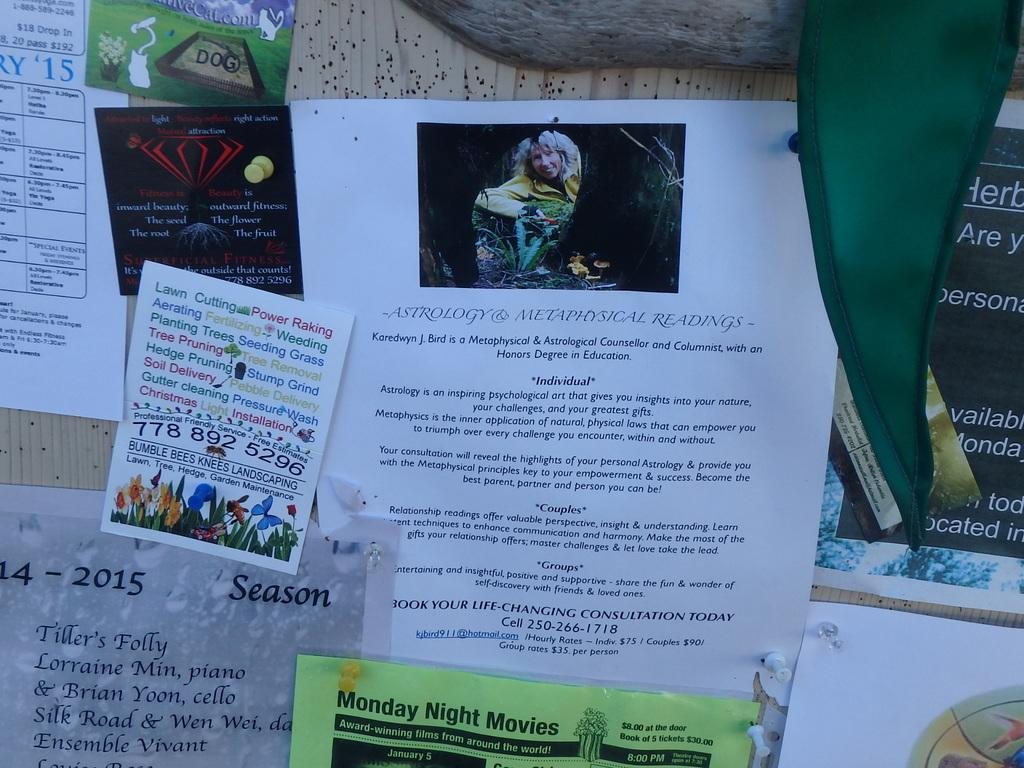What is displayed on the board in the image? There are papers attached to a board in the image, which contain text and an image of a person. What is the color of the cloth in the top right corner of the image? The cloth in the top right corner of the image is green. What type of nail is being used to hold the papers on the board? There is no nail visible in the image; the papers are attached to the board without any visible fasteners. 